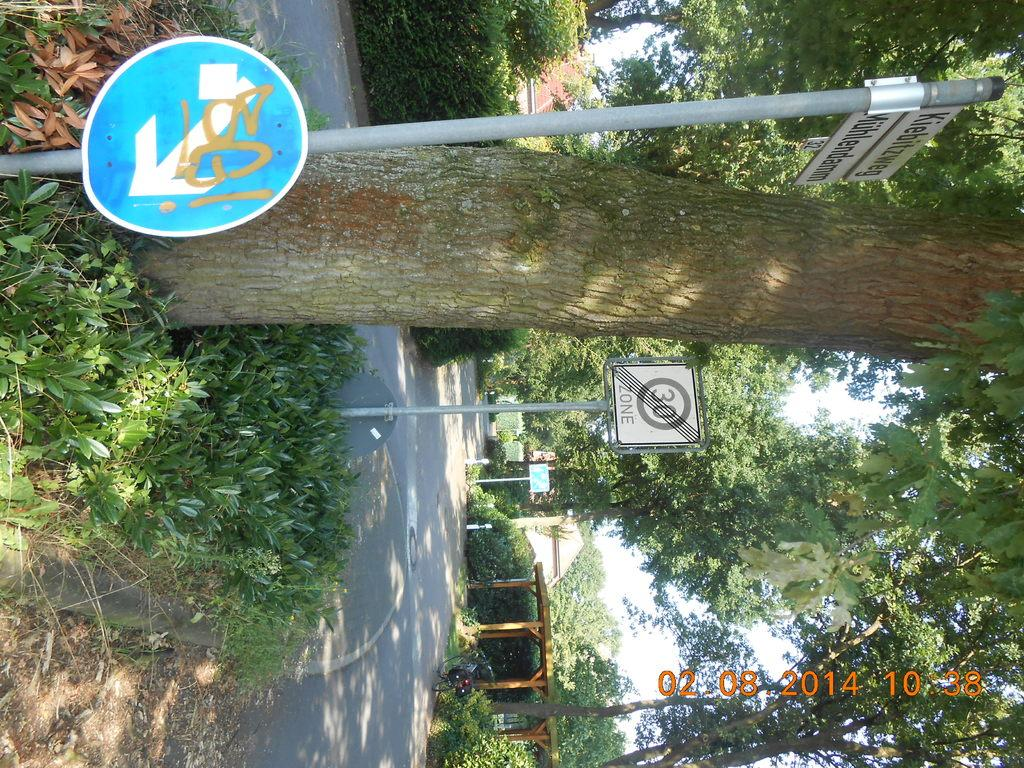<image>
Share a concise interpretation of the image provided. A sideways view of a 30 ZONE sign next to a tree. 